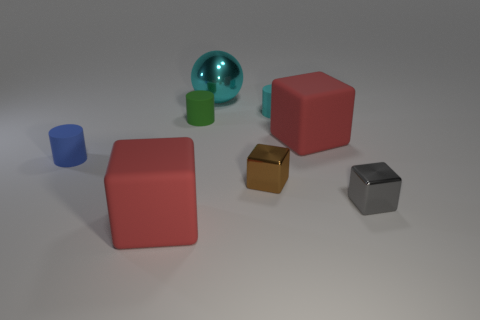Do the big block behind the blue rubber object and the metallic object that is behind the small blue thing have the same color?
Offer a terse response. No. There is a small green cylinder in front of the cyan metal thing; what is it made of?
Offer a very short reply. Rubber. There is a large ball that is made of the same material as the gray cube; what is its color?
Offer a terse response. Cyan. How many blue rubber objects are the same size as the gray metal object?
Your response must be concise. 1. Do the cyan cylinder right of the blue object and the small green object have the same size?
Offer a very short reply. Yes. What shape is the small thing that is in front of the small blue matte cylinder and on the left side of the small gray metallic thing?
Keep it short and to the point. Cube. Are there any tiny blue objects behind the small cyan cylinder?
Ensure brevity in your answer.  No. Are there any other things that have the same shape as the tiny brown thing?
Your answer should be compact. Yes. Does the small green matte thing have the same shape as the cyan metal object?
Provide a succinct answer. No. Are there the same number of matte objects right of the tiny blue cylinder and small gray things left of the gray metal cube?
Your response must be concise. No. 